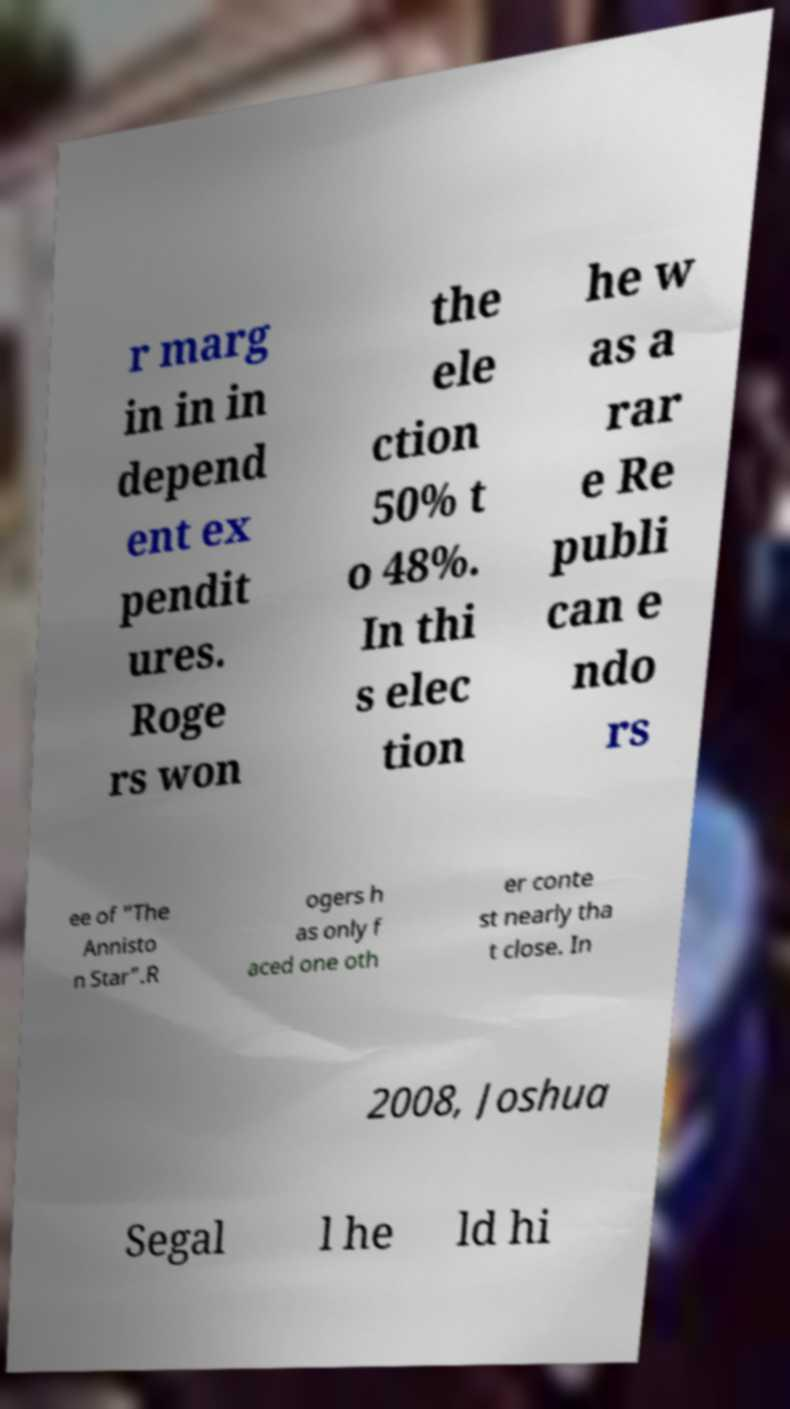Please identify and transcribe the text found in this image. r marg in in in depend ent ex pendit ures. Roge rs won the ele ction 50% t o 48%. In thi s elec tion he w as a rar e Re publi can e ndo rs ee of "The Annisto n Star".R ogers h as only f aced one oth er conte st nearly tha t close. In 2008, Joshua Segal l he ld hi 